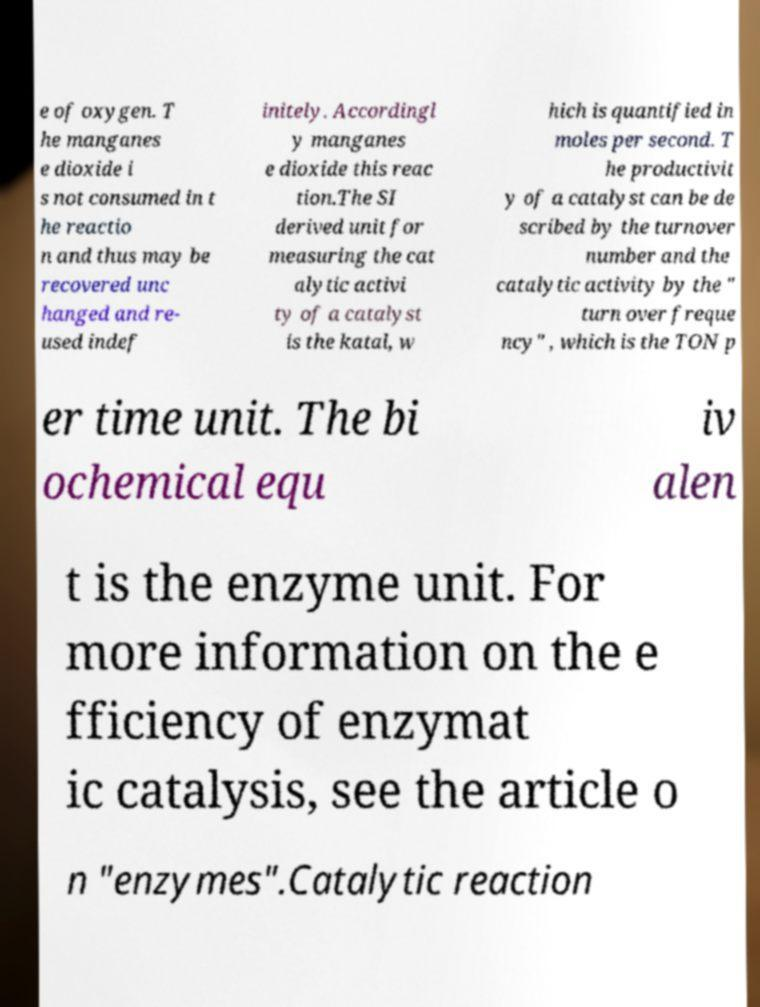Can you read and provide the text displayed in the image?This photo seems to have some interesting text. Can you extract and type it out for me? e of oxygen. T he manganes e dioxide i s not consumed in t he reactio n and thus may be recovered unc hanged and re- used indef initely. Accordingl y manganes e dioxide this reac tion.The SI derived unit for measuring the cat alytic activi ty of a catalyst is the katal, w hich is quantified in moles per second. T he productivit y of a catalyst can be de scribed by the turnover number and the catalytic activity by the " turn over freque ncy" , which is the TON p er time unit. The bi ochemical equ iv alen t is the enzyme unit. For more information on the e fficiency of enzymat ic catalysis, see the article o n "enzymes".Catalytic reaction 